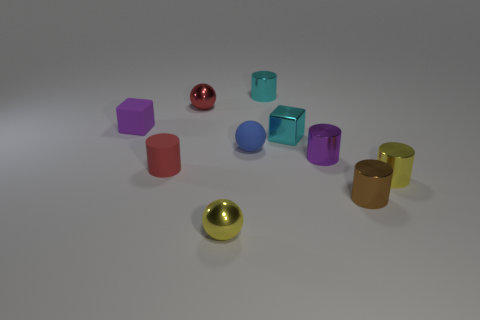Subtract all tiny brown cylinders. How many cylinders are left? 4 Subtract 1 spheres. How many spheres are left? 2 Subtract all cyan cylinders. How many cylinders are left? 4 Subtract all balls. How many objects are left? 7 Subtract all yellow cylinders. Subtract all green cubes. How many cylinders are left? 4 Subtract all brown cylinders. Subtract all tiny matte things. How many objects are left? 6 Add 2 tiny red rubber cylinders. How many tiny red rubber cylinders are left? 3 Add 1 brown cylinders. How many brown cylinders exist? 2 Subtract 1 yellow spheres. How many objects are left? 9 